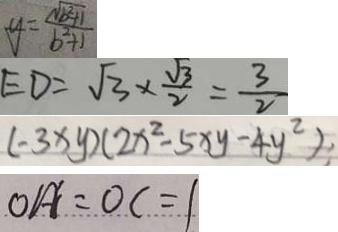Convert formula to latex. <formula><loc_0><loc_0><loc_500><loc_500>y = \frac { \sqrt { b ^ { 2 } + 1 } } { b ^ { 2 } + 1 } 
 E D = \sqrt { 3 } \times \frac { \sqrt { 3 } } { 2 } = \frac { 3 } { 2 } 
 ( - 3 x y ) ( 2 x ^ { 2 } - 5 x y - 4 y ^ { 2 } ) 
 O A ^ { \prime } = O C = 1</formula> 